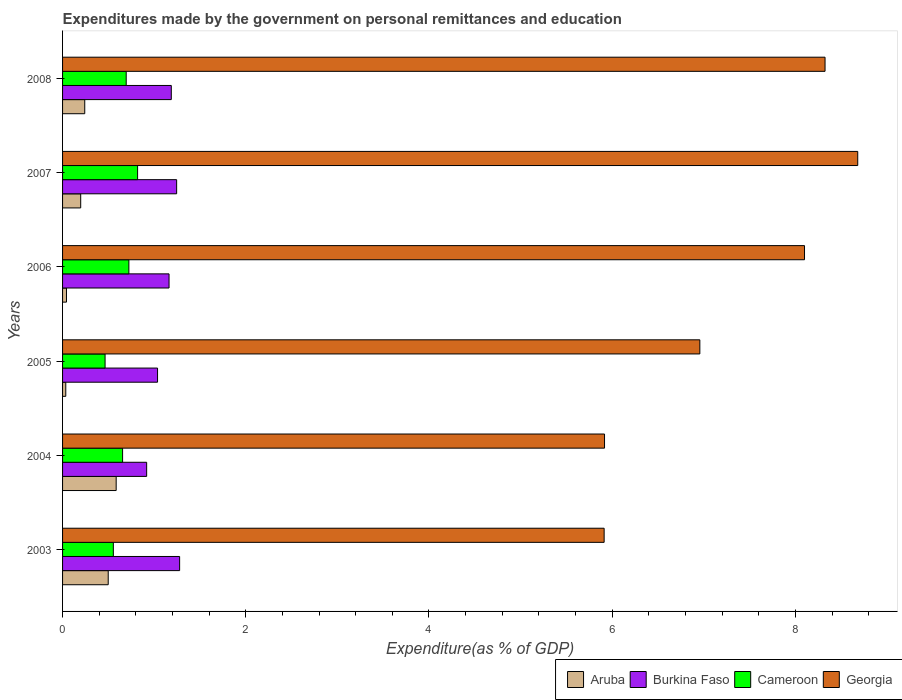How many different coloured bars are there?
Make the answer very short. 4. How many groups of bars are there?
Provide a succinct answer. 6. Are the number of bars on each tick of the Y-axis equal?
Provide a succinct answer. Yes. How many bars are there on the 2nd tick from the top?
Make the answer very short. 4. How many bars are there on the 4th tick from the bottom?
Make the answer very short. 4. What is the expenditures made by the government on personal remittances and education in Cameroon in 2005?
Your response must be concise. 0.46. Across all years, what is the maximum expenditures made by the government on personal remittances and education in Georgia?
Your response must be concise. 8.68. Across all years, what is the minimum expenditures made by the government on personal remittances and education in Burkina Faso?
Ensure brevity in your answer.  0.92. What is the total expenditures made by the government on personal remittances and education in Cameroon in the graph?
Make the answer very short. 3.91. What is the difference between the expenditures made by the government on personal remittances and education in Cameroon in 2004 and that in 2007?
Your answer should be very brief. -0.16. What is the difference between the expenditures made by the government on personal remittances and education in Aruba in 2004 and the expenditures made by the government on personal remittances and education in Burkina Faso in 2008?
Your answer should be compact. -0.6. What is the average expenditures made by the government on personal remittances and education in Burkina Faso per year?
Ensure brevity in your answer.  1.14. In the year 2008, what is the difference between the expenditures made by the government on personal remittances and education in Georgia and expenditures made by the government on personal remittances and education in Aruba?
Give a very brief answer. 8.08. What is the ratio of the expenditures made by the government on personal remittances and education in Burkina Faso in 2006 to that in 2007?
Make the answer very short. 0.93. Is the difference between the expenditures made by the government on personal remittances and education in Georgia in 2004 and 2005 greater than the difference between the expenditures made by the government on personal remittances and education in Aruba in 2004 and 2005?
Offer a terse response. No. What is the difference between the highest and the second highest expenditures made by the government on personal remittances and education in Aruba?
Keep it short and to the point. 0.09. What is the difference between the highest and the lowest expenditures made by the government on personal remittances and education in Georgia?
Give a very brief answer. 2.77. What does the 3rd bar from the top in 2006 represents?
Provide a succinct answer. Burkina Faso. What does the 1st bar from the bottom in 2004 represents?
Offer a terse response. Aruba. What is the difference between two consecutive major ticks on the X-axis?
Make the answer very short. 2. Does the graph contain any zero values?
Offer a very short reply. No. Does the graph contain grids?
Ensure brevity in your answer.  No. Where does the legend appear in the graph?
Offer a terse response. Bottom right. How many legend labels are there?
Ensure brevity in your answer.  4. What is the title of the graph?
Give a very brief answer. Expenditures made by the government on personal remittances and education. Does "China" appear as one of the legend labels in the graph?
Offer a terse response. No. What is the label or title of the X-axis?
Give a very brief answer. Expenditure(as % of GDP). What is the Expenditure(as % of GDP) in Aruba in 2003?
Make the answer very short. 0.5. What is the Expenditure(as % of GDP) in Burkina Faso in 2003?
Keep it short and to the point. 1.28. What is the Expenditure(as % of GDP) of Cameroon in 2003?
Your answer should be very brief. 0.55. What is the Expenditure(as % of GDP) in Georgia in 2003?
Keep it short and to the point. 5.91. What is the Expenditure(as % of GDP) of Aruba in 2004?
Provide a short and direct response. 0.59. What is the Expenditure(as % of GDP) of Burkina Faso in 2004?
Keep it short and to the point. 0.92. What is the Expenditure(as % of GDP) of Cameroon in 2004?
Offer a terse response. 0.66. What is the Expenditure(as % of GDP) of Georgia in 2004?
Give a very brief answer. 5.92. What is the Expenditure(as % of GDP) of Aruba in 2005?
Provide a succinct answer. 0.04. What is the Expenditure(as % of GDP) of Burkina Faso in 2005?
Your response must be concise. 1.04. What is the Expenditure(as % of GDP) of Cameroon in 2005?
Provide a short and direct response. 0.46. What is the Expenditure(as % of GDP) of Georgia in 2005?
Give a very brief answer. 6.96. What is the Expenditure(as % of GDP) in Aruba in 2006?
Give a very brief answer. 0.04. What is the Expenditure(as % of GDP) of Burkina Faso in 2006?
Your response must be concise. 1.16. What is the Expenditure(as % of GDP) in Cameroon in 2006?
Provide a succinct answer. 0.72. What is the Expenditure(as % of GDP) of Georgia in 2006?
Ensure brevity in your answer.  8.1. What is the Expenditure(as % of GDP) of Aruba in 2007?
Your answer should be compact. 0.2. What is the Expenditure(as % of GDP) of Burkina Faso in 2007?
Ensure brevity in your answer.  1.25. What is the Expenditure(as % of GDP) of Cameroon in 2007?
Your answer should be compact. 0.82. What is the Expenditure(as % of GDP) in Georgia in 2007?
Offer a terse response. 8.68. What is the Expenditure(as % of GDP) of Aruba in 2008?
Give a very brief answer. 0.24. What is the Expenditure(as % of GDP) in Burkina Faso in 2008?
Your response must be concise. 1.19. What is the Expenditure(as % of GDP) in Cameroon in 2008?
Give a very brief answer. 0.69. What is the Expenditure(as % of GDP) of Georgia in 2008?
Ensure brevity in your answer.  8.32. Across all years, what is the maximum Expenditure(as % of GDP) of Aruba?
Offer a terse response. 0.59. Across all years, what is the maximum Expenditure(as % of GDP) of Burkina Faso?
Keep it short and to the point. 1.28. Across all years, what is the maximum Expenditure(as % of GDP) in Cameroon?
Give a very brief answer. 0.82. Across all years, what is the maximum Expenditure(as % of GDP) in Georgia?
Offer a very short reply. 8.68. Across all years, what is the minimum Expenditure(as % of GDP) of Aruba?
Offer a very short reply. 0.04. Across all years, what is the minimum Expenditure(as % of GDP) of Burkina Faso?
Ensure brevity in your answer.  0.92. Across all years, what is the minimum Expenditure(as % of GDP) of Cameroon?
Offer a terse response. 0.46. Across all years, what is the minimum Expenditure(as % of GDP) of Georgia?
Offer a very short reply. 5.91. What is the total Expenditure(as % of GDP) in Aruba in the graph?
Provide a succinct answer. 1.6. What is the total Expenditure(as % of GDP) of Burkina Faso in the graph?
Ensure brevity in your answer.  6.83. What is the total Expenditure(as % of GDP) in Cameroon in the graph?
Offer a terse response. 3.91. What is the total Expenditure(as % of GDP) of Georgia in the graph?
Ensure brevity in your answer.  43.89. What is the difference between the Expenditure(as % of GDP) of Aruba in 2003 and that in 2004?
Provide a succinct answer. -0.09. What is the difference between the Expenditure(as % of GDP) in Burkina Faso in 2003 and that in 2004?
Ensure brevity in your answer.  0.36. What is the difference between the Expenditure(as % of GDP) of Cameroon in 2003 and that in 2004?
Offer a very short reply. -0.1. What is the difference between the Expenditure(as % of GDP) in Georgia in 2003 and that in 2004?
Offer a very short reply. -0. What is the difference between the Expenditure(as % of GDP) of Aruba in 2003 and that in 2005?
Give a very brief answer. 0.46. What is the difference between the Expenditure(as % of GDP) in Burkina Faso in 2003 and that in 2005?
Your response must be concise. 0.24. What is the difference between the Expenditure(as % of GDP) in Cameroon in 2003 and that in 2005?
Offer a very short reply. 0.09. What is the difference between the Expenditure(as % of GDP) in Georgia in 2003 and that in 2005?
Your response must be concise. -1.04. What is the difference between the Expenditure(as % of GDP) of Aruba in 2003 and that in 2006?
Provide a succinct answer. 0.46. What is the difference between the Expenditure(as % of GDP) in Burkina Faso in 2003 and that in 2006?
Keep it short and to the point. 0.12. What is the difference between the Expenditure(as % of GDP) of Cameroon in 2003 and that in 2006?
Give a very brief answer. -0.17. What is the difference between the Expenditure(as % of GDP) of Georgia in 2003 and that in 2006?
Provide a succinct answer. -2.19. What is the difference between the Expenditure(as % of GDP) in Aruba in 2003 and that in 2007?
Make the answer very short. 0.3. What is the difference between the Expenditure(as % of GDP) of Burkina Faso in 2003 and that in 2007?
Give a very brief answer. 0.03. What is the difference between the Expenditure(as % of GDP) in Cameroon in 2003 and that in 2007?
Make the answer very short. -0.26. What is the difference between the Expenditure(as % of GDP) of Georgia in 2003 and that in 2007?
Provide a short and direct response. -2.77. What is the difference between the Expenditure(as % of GDP) in Aruba in 2003 and that in 2008?
Ensure brevity in your answer.  0.26. What is the difference between the Expenditure(as % of GDP) of Burkina Faso in 2003 and that in 2008?
Keep it short and to the point. 0.09. What is the difference between the Expenditure(as % of GDP) in Cameroon in 2003 and that in 2008?
Your answer should be compact. -0.14. What is the difference between the Expenditure(as % of GDP) in Georgia in 2003 and that in 2008?
Give a very brief answer. -2.41. What is the difference between the Expenditure(as % of GDP) in Aruba in 2004 and that in 2005?
Offer a terse response. 0.55. What is the difference between the Expenditure(as % of GDP) of Burkina Faso in 2004 and that in 2005?
Ensure brevity in your answer.  -0.12. What is the difference between the Expenditure(as % of GDP) in Cameroon in 2004 and that in 2005?
Keep it short and to the point. 0.19. What is the difference between the Expenditure(as % of GDP) of Georgia in 2004 and that in 2005?
Ensure brevity in your answer.  -1.04. What is the difference between the Expenditure(as % of GDP) in Aruba in 2004 and that in 2006?
Keep it short and to the point. 0.54. What is the difference between the Expenditure(as % of GDP) of Burkina Faso in 2004 and that in 2006?
Your response must be concise. -0.24. What is the difference between the Expenditure(as % of GDP) in Cameroon in 2004 and that in 2006?
Offer a very short reply. -0.07. What is the difference between the Expenditure(as % of GDP) in Georgia in 2004 and that in 2006?
Make the answer very short. -2.18. What is the difference between the Expenditure(as % of GDP) of Aruba in 2004 and that in 2007?
Give a very brief answer. 0.39. What is the difference between the Expenditure(as % of GDP) in Burkina Faso in 2004 and that in 2007?
Offer a very short reply. -0.33. What is the difference between the Expenditure(as % of GDP) in Cameroon in 2004 and that in 2007?
Make the answer very short. -0.16. What is the difference between the Expenditure(as % of GDP) of Georgia in 2004 and that in 2007?
Your response must be concise. -2.76. What is the difference between the Expenditure(as % of GDP) in Aruba in 2004 and that in 2008?
Offer a terse response. 0.34. What is the difference between the Expenditure(as % of GDP) in Burkina Faso in 2004 and that in 2008?
Make the answer very short. -0.27. What is the difference between the Expenditure(as % of GDP) in Cameroon in 2004 and that in 2008?
Your answer should be compact. -0.04. What is the difference between the Expenditure(as % of GDP) in Georgia in 2004 and that in 2008?
Provide a short and direct response. -2.41. What is the difference between the Expenditure(as % of GDP) in Aruba in 2005 and that in 2006?
Provide a short and direct response. -0.01. What is the difference between the Expenditure(as % of GDP) of Burkina Faso in 2005 and that in 2006?
Your answer should be very brief. -0.13. What is the difference between the Expenditure(as % of GDP) in Cameroon in 2005 and that in 2006?
Keep it short and to the point. -0.26. What is the difference between the Expenditure(as % of GDP) of Georgia in 2005 and that in 2006?
Your answer should be compact. -1.14. What is the difference between the Expenditure(as % of GDP) in Aruba in 2005 and that in 2007?
Give a very brief answer. -0.16. What is the difference between the Expenditure(as % of GDP) in Burkina Faso in 2005 and that in 2007?
Make the answer very short. -0.21. What is the difference between the Expenditure(as % of GDP) of Cameroon in 2005 and that in 2007?
Your answer should be very brief. -0.35. What is the difference between the Expenditure(as % of GDP) of Georgia in 2005 and that in 2007?
Your response must be concise. -1.72. What is the difference between the Expenditure(as % of GDP) in Aruba in 2005 and that in 2008?
Ensure brevity in your answer.  -0.21. What is the difference between the Expenditure(as % of GDP) in Burkina Faso in 2005 and that in 2008?
Your answer should be very brief. -0.15. What is the difference between the Expenditure(as % of GDP) of Cameroon in 2005 and that in 2008?
Offer a terse response. -0.23. What is the difference between the Expenditure(as % of GDP) of Georgia in 2005 and that in 2008?
Your answer should be compact. -1.37. What is the difference between the Expenditure(as % of GDP) of Aruba in 2006 and that in 2007?
Provide a succinct answer. -0.16. What is the difference between the Expenditure(as % of GDP) of Burkina Faso in 2006 and that in 2007?
Provide a succinct answer. -0.08. What is the difference between the Expenditure(as % of GDP) in Cameroon in 2006 and that in 2007?
Provide a succinct answer. -0.1. What is the difference between the Expenditure(as % of GDP) of Georgia in 2006 and that in 2007?
Your answer should be compact. -0.58. What is the difference between the Expenditure(as % of GDP) in Aruba in 2006 and that in 2008?
Your answer should be very brief. -0.2. What is the difference between the Expenditure(as % of GDP) of Burkina Faso in 2006 and that in 2008?
Offer a terse response. -0.02. What is the difference between the Expenditure(as % of GDP) in Cameroon in 2006 and that in 2008?
Make the answer very short. 0.03. What is the difference between the Expenditure(as % of GDP) of Georgia in 2006 and that in 2008?
Offer a very short reply. -0.22. What is the difference between the Expenditure(as % of GDP) of Aruba in 2007 and that in 2008?
Give a very brief answer. -0.04. What is the difference between the Expenditure(as % of GDP) in Burkina Faso in 2007 and that in 2008?
Give a very brief answer. 0.06. What is the difference between the Expenditure(as % of GDP) of Cameroon in 2007 and that in 2008?
Ensure brevity in your answer.  0.12. What is the difference between the Expenditure(as % of GDP) of Georgia in 2007 and that in 2008?
Keep it short and to the point. 0.36. What is the difference between the Expenditure(as % of GDP) of Aruba in 2003 and the Expenditure(as % of GDP) of Burkina Faso in 2004?
Your answer should be very brief. -0.42. What is the difference between the Expenditure(as % of GDP) in Aruba in 2003 and the Expenditure(as % of GDP) in Cameroon in 2004?
Your answer should be very brief. -0.16. What is the difference between the Expenditure(as % of GDP) of Aruba in 2003 and the Expenditure(as % of GDP) of Georgia in 2004?
Give a very brief answer. -5.42. What is the difference between the Expenditure(as % of GDP) of Burkina Faso in 2003 and the Expenditure(as % of GDP) of Cameroon in 2004?
Give a very brief answer. 0.62. What is the difference between the Expenditure(as % of GDP) of Burkina Faso in 2003 and the Expenditure(as % of GDP) of Georgia in 2004?
Your answer should be compact. -4.64. What is the difference between the Expenditure(as % of GDP) of Cameroon in 2003 and the Expenditure(as % of GDP) of Georgia in 2004?
Keep it short and to the point. -5.36. What is the difference between the Expenditure(as % of GDP) of Aruba in 2003 and the Expenditure(as % of GDP) of Burkina Faso in 2005?
Make the answer very short. -0.54. What is the difference between the Expenditure(as % of GDP) in Aruba in 2003 and the Expenditure(as % of GDP) in Cameroon in 2005?
Keep it short and to the point. 0.03. What is the difference between the Expenditure(as % of GDP) of Aruba in 2003 and the Expenditure(as % of GDP) of Georgia in 2005?
Offer a terse response. -6.46. What is the difference between the Expenditure(as % of GDP) in Burkina Faso in 2003 and the Expenditure(as % of GDP) in Cameroon in 2005?
Your response must be concise. 0.81. What is the difference between the Expenditure(as % of GDP) in Burkina Faso in 2003 and the Expenditure(as % of GDP) in Georgia in 2005?
Provide a succinct answer. -5.68. What is the difference between the Expenditure(as % of GDP) in Cameroon in 2003 and the Expenditure(as % of GDP) in Georgia in 2005?
Provide a short and direct response. -6.4. What is the difference between the Expenditure(as % of GDP) in Aruba in 2003 and the Expenditure(as % of GDP) in Burkina Faso in 2006?
Make the answer very short. -0.66. What is the difference between the Expenditure(as % of GDP) of Aruba in 2003 and the Expenditure(as % of GDP) of Cameroon in 2006?
Offer a terse response. -0.23. What is the difference between the Expenditure(as % of GDP) of Aruba in 2003 and the Expenditure(as % of GDP) of Georgia in 2006?
Offer a terse response. -7.6. What is the difference between the Expenditure(as % of GDP) in Burkina Faso in 2003 and the Expenditure(as % of GDP) in Cameroon in 2006?
Give a very brief answer. 0.55. What is the difference between the Expenditure(as % of GDP) of Burkina Faso in 2003 and the Expenditure(as % of GDP) of Georgia in 2006?
Ensure brevity in your answer.  -6.82. What is the difference between the Expenditure(as % of GDP) of Cameroon in 2003 and the Expenditure(as % of GDP) of Georgia in 2006?
Your answer should be compact. -7.55. What is the difference between the Expenditure(as % of GDP) of Aruba in 2003 and the Expenditure(as % of GDP) of Burkina Faso in 2007?
Make the answer very short. -0.75. What is the difference between the Expenditure(as % of GDP) of Aruba in 2003 and the Expenditure(as % of GDP) of Cameroon in 2007?
Offer a very short reply. -0.32. What is the difference between the Expenditure(as % of GDP) of Aruba in 2003 and the Expenditure(as % of GDP) of Georgia in 2007?
Give a very brief answer. -8.18. What is the difference between the Expenditure(as % of GDP) of Burkina Faso in 2003 and the Expenditure(as % of GDP) of Cameroon in 2007?
Provide a succinct answer. 0.46. What is the difference between the Expenditure(as % of GDP) in Burkina Faso in 2003 and the Expenditure(as % of GDP) in Georgia in 2007?
Provide a succinct answer. -7.4. What is the difference between the Expenditure(as % of GDP) of Cameroon in 2003 and the Expenditure(as % of GDP) of Georgia in 2007?
Your answer should be compact. -8.13. What is the difference between the Expenditure(as % of GDP) of Aruba in 2003 and the Expenditure(as % of GDP) of Burkina Faso in 2008?
Offer a terse response. -0.69. What is the difference between the Expenditure(as % of GDP) in Aruba in 2003 and the Expenditure(as % of GDP) in Cameroon in 2008?
Ensure brevity in your answer.  -0.2. What is the difference between the Expenditure(as % of GDP) of Aruba in 2003 and the Expenditure(as % of GDP) of Georgia in 2008?
Your answer should be very brief. -7.83. What is the difference between the Expenditure(as % of GDP) of Burkina Faso in 2003 and the Expenditure(as % of GDP) of Cameroon in 2008?
Provide a short and direct response. 0.58. What is the difference between the Expenditure(as % of GDP) of Burkina Faso in 2003 and the Expenditure(as % of GDP) of Georgia in 2008?
Your answer should be very brief. -7.05. What is the difference between the Expenditure(as % of GDP) of Cameroon in 2003 and the Expenditure(as % of GDP) of Georgia in 2008?
Offer a very short reply. -7.77. What is the difference between the Expenditure(as % of GDP) of Aruba in 2004 and the Expenditure(as % of GDP) of Burkina Faso in 2005?
Your answer should be very brief. -0.45. What is the difference between the Expenditure(as % of GDP) in Aruba in 2004 and the Expenditure(as % of GDP) in Cameroon in 2005?
Your answer should be compact. 0.12. What is the difference between the Expenditure(as % of GDP) in Aruba in 2004 and the Expenditure(as % of GDP) in Georgia in 2005?
Offer a terse response. -6.37. What is the difference between the Expenditure(as % of GDP) in Burkina Faso in 2004 and the Expenditure(as % of GDP) in Cameroon in 2005?
Provide a succinct answer. 0.45. What is the difference between the Expenditure(as % of GDP) of Burkina Faso in 2004 and the Expenditure(as % of GDP) of Georgia in 2005?
Offer a very short reply. -6.04. What is the difference between the Expenditure(as % of GDP) of Cameroon in 2004 and the Expenditure(as % of GDP) of Georgia in 2005?
Offer a terse response. -6.3. What is the difference between the Expenditure(as % of GDP) in Aruba in 2004 and the Expenditure(as % of GDP) in Burkina Faso in 2006?
Provide a succinct answer. -0.58. What is the difference between the Expenditure(as % of GDP) in Aruba in 2004 and the Expenditure(as % of GDP) in Cameroon in 2006?
Ensure brevity in your answer.  -0.14. What is the difference between the Expenditure(as % of GDP) in Aruba in 2004 and the Expenditure(as % of GDP) in Georgia in 2006?
Give a very brief answer. -7.51. What is the difference between the Expenditure(as % of GDP) of Burkina Faso in 2004 and the Expenditure(as % of GDP) of Cameroon in 2006?
Make the answer very short. 0.19. What is the difference between the Expenditure(as % of GDP) in Burkina Faso in 2004 and the Expenditure(as % of GDP) in Georgia in 2006?
Provide a short and direct response. -7.18. What is the difference between the Expenditure(as % of GDP) of Cameroon in 2004 and the Expenditure(as % of GDP) of Georgia in 2006?
Offer a very short reply. -7.44. What is the difference between the Expenditure(as % of GDP) of Aruba in 2004 and the Expenditure(as % of GDP) of Burkina Faso in 2007?
Provide a succinct answer. -0.66. What is the difference between the Expenditure(as % of GDP) of Aruba in 2004 and the Expenditure(as % of GDP) of Cameroon in 2007?
Give a very brief answer. -0.23. What is the difference between the Expenditure(as % of GDP) in Aruba in 2004 and the Expenditure(as % of GDP) in Georgia in 2007?
Give a very brief answer. -8.1. What is the difference between the Expenditure(as % of GDP) in Burkina Faso in 2004 and the Expenditure(as % of GDP) in Cameroon in 2007?
Ensure brevity in your answer.  0.1. What is the difference between the Expenditure(as % of GDP) in Burkina Faso in 2004 and the Expenditure(as % of GDP) in Georgia in 2007?
Your answer should be very brief. -7.76. What is the difference between the Expenditure(as % of GDP) of Cameroon in 2004 and the Expenditure(as % of GDP) of Georgia in 2007?
Your response must be concise. -8.03. What is the difference between the Expenditure(as % of GDP) of Aruba in 2004 and the Expenditure(as % of GDP) of Burkina Faso in 2008?
Provide a succinct answer. -0.6. What is the difference between the Expenditure(as % of GDP) in Aruba in 2004 and the Expenditure(as % of GDP) in Cameroon in 2008?
Provide a succinct answer. -0.11. What is the difference between the Expenditure(as % of GDP) in Aruba in 2004 and the Expenditure(as % of GDP) in Georgia in 2008?
Offer a very short reply. -7.74. What is the difference between the Expenditure(as % of GDP) of Burkina Faso in 2004 and the Expenditure(as % of GDP) of Cameroon in 2008?
Your response must be concise. 0.22. What is the difference between the Expenditure(as % of GDP) of Burkina Faso in 2004 and the Expenditure(as % of GDP) of Georgia in 2008?
Your response must be concise. -7.41. What is the difference between the Expenditure(as % of GDP) of Cameroon in 2004 and the Expenditure(as % of GDP) of Georgia in 2008?
Offer a very short reply. -7.67. What is the difference between the Expenditure(as % of GDP) of Aruba in 2005 and the Expenditure(as % of GDP) of Burkina Faso in 2006?
Give a very brief answer. -1.13. What is the difference between the Expenditure(as % of GDP) of Aruba in 2005 and the Expenditure(as % of GDP) of Cameroon in 2006?
Your response must be concise. -0.69. What is the difference between the Expenditure(as % of GDP) in Aruba in 2005 and the Expenditure(as % of GDP) in Georgia in 2006?
Keep it short and to the point. -8.06. What is the difference between the Expenditure(as % of GDP) in Burkina Faso in 2005 and the Expenditure(as % of GDP) in Cameroon in 2006?
Provide a short and direct response. 0.31. What is the difference between the Expenditure(as % of GDP) in Burkina Faso in 2005 and the Expenditure(as % of GDP) in Georgia in 2006?
Your answer should be compact. -7.06. What is the difference between the Expenditure(as % of GDP) in Cameroon in 2005 and the Expenditure(as % of GDP) in Georgia in 2006?
Keep it short and to the point. -7.64. What is the difference between the Expenditure(as % of GDP) in Aruba in 2005 and the Expenditure(as % of GDP) in Burkina Faso in 2007?
Provide a succinct answer. -1.21. What is the difference between the Expenditure(as % of GDP) of Aruba in 2005 and the Expenditure(as % of GDP) of Cameroon in 2007?
Provide a short and direct response. -0.78. What is the difference between the Expenditure(as % of GDP) of Aruba in 2005 and the Expenditure(as % of GDP) of Georgia in 2007?
Offer a terse response. -8.65. What is the difference between the Expenditure(as % of GDP) of Burkina Faso in 2005 and the Expenditure(as % of GDP) of Cameroon in 2007?
Keep it short and to the point. 0.22. What is the difference between the Expenditure(as % of GDP) of Burkina Faso in 2005 and the Expenditure(as % of GDP) of Georgia in 2007?
Your response must be concise. -7.64. What is the difference between the Expenditure(as % of GDP) in Cameroon in 2005 and the Expenditure(as % of GDP) in Georgia in 2007?
Provide a short and direct response. -8.22. What is the difference between the Expenditure(as % of GDP) of Aruba in 2005 and the Expenditure(as % of GDP) of Burkina Faso in 2008?
Ensure brevity in your answer.  -1.15. What is the difference between the Expenditure(as % of GDP) in Aruba in 2005 and the Expenditure(as % of GDP) in Cameroon in 2008?
Your answer should be very brief. -0.66. What is the difference between the Expenditure(as % of GDP) in Aruba in 2005 and the Expenditure(as % of GDP) in Georgia in 2008?
Your answer should be very brief. -8.29. What is the difference between the Expenditure(as % of GDP) in Burkina Faso in 2005 and the Expenditure(as % of GDP) in Cameroon in 2008?
Offer a very short reply. 0.34. What is the difference between the Expenditure(as % of GDP) in Burkina Faso in 2005 and the Expenditure(as % of GDP) in Georgia in 2008?
Your response must be concise. -7.29. What is the difference between the Expenditure(as % of GDP) in Cameroon in 2005 and the Expenditure(as % of GDP) in Georgia in 2008?
Ensure brevity in your answer.  -7.86. What is the difference between the Expenditure(as % of GDP) of Aruba in 2006 and the Expenditure(as % of GDP) of Burkina Faso in 2007?
Your answer should be very brief. -1.2. What is the difference between the Expenditure(as % of GDP) of Aruba in 2006 and the Expenditure(as % of GDP) of Cameroon in 2007?
Your answer should be compact. -0.78. What is the difference between the Expenditure(as % of GDP) in Aruba in 2006 and the Expenditure(as % of GDP) in Georgia in 2007?
Keep it short and to the point. -8.64. What is the difference between the Expenditure(as % of GDP) of Burkina Faso in 2006 and the Expenditure(as % of GDP) of Cameroon in 2007?
Your response must be concise. 0.34. What is the difference between the Expenditure(as % of GDP) of Burkina Faso in 2006 and the Expenditure(as % of GDP) of Georgia in 2007?
Offer a very short reply. -7.52. What is the difference between the Expenditure(as % of GDP) in Cameroon in 2006 and the Expenditure(as % of GDP) in Georgia in 2007?
Ensure brevity in your answer.  -7.96. What is the difference between the Expenditure(as % of GDP) of Aruba in 2006 and the Expenditure(as % of GDP) of Burkina Faso in 2008?
Provide a short and direct response. -1.14. What is the difference between the Expenditure(as % of GDP) of Aruba in 2006 and the Expenditure(as % of GDP) of Cameroon in 2008?
Offer a terse response. -0.65. What is the difference between the Expenditure(as % of GDP) of Aruba in 2006 and the Expenditure(as % of GDP) of Georgia in 2008?
Make the answer very short. -8.28. What is the difference between the Expenditure(as % of GDP) of Burkina Faso in 2006 and the Expenditure(as % of GDP) of Cameroon in 2008?
Ensure brevity in your answer.  0.47. What is the difference between the Expenditure(as % of GDP) of Burkina Faso in 2006 and the Expenditure(as % of GDP) of Georgia in 2008?
Your answer should be very brief. -7.16. What is the difference between the Expenditure(as % of GDP) in Cameroon in 2006 and the Expenditure(as % of GDP) in Georgia in 2008?
Ensure brevity in your answer.  -7.6. What is the difference between the Expenditure(as % of GDP) of Aruba in 2007 and the Expenditure(as % of GDP) of Burkina Faso in 2008?
Keep it short and to the point. -0.99. What is the difference between the Expenditure(as % of GDP) in Aruba in 2007 and the Expenditure(as % of GDP) in Cameroon in 2008?
Provide a short and direct response. -0.5. What is the difference between the Expenditure(as % of GDP) of Aruba in 2007 and the Expenditure(as % of GDP) of Georgia in 2008?
Your response must be concise. -8.13. What is the difference between the Expenditure(as % of GDP) in Burkina Faso in 2007 and the Expenditure(as % of GDP) in Cameroon in 2008?
Ensure brevity in your answer.  0.55. What is the difference between the Expenditure(as % of GDP) in Burkina Faso in 2007 and the Expenditure(as % of GDP) in Georgia in 2008?
Your answer should be very brief. -7.08. What is the difference between the Expenditure(as % of GDP) of Cameroon in 2007 and the Expenditure(as % of GDP) of Georgia in 2008?
Your response must be concise. -7.5. What is the average Expenditure(as % of GDP) in Aruba per year?
Provide a short and direct response. 0.27. What is the average Expenditure(as % of GDP) in Burkina Faso per year?
Your response must be concise. 1.14. What is the average Expenditure(as % of GDP) of Cameroon per year?
Your response must be concise. 0.65. What is the average Expenditure(as % of GDP) in Georgia per year?
Give a very brief answer. 7.31. In the year 2003, what is the difference between the Expenditure(as % of GDP) of Aruba and Expenditure(as % of GDP) of Burkina Faso?
Give a very brief answer. -0.78. In the year 2003, what is the difference between the Expenditure(as % of GDP) of Aruba and Expenditure(as % of GDP) of Cameroon?
Your response must be concise. -0.06. In the year 2003, what is the difference between the Expenditure(as % of GDP) of Aruba and Expenditure(as % of GDP) of Georgia?
Offer a very short reply. -5.41. In the year 2003, what is the difference between the Expenditure(as % of GDP) in Burkina Faso and Expenditure(as % of GDP) in Cameroon?
Offer a terse response. 0.72. In the year 2003, what is the difference between the Expenditure(as % of GDP) of Burkina Faso and Expenditure(as % of GDP) of Georgia?
Give a very brief answer. -4.63. In the year 2003, what is the difference between the Expenditure(as % of GDP) in Cameroon and Expenditure(as % of GDP) in Georgia?
Offer a terse response. -5.36. In the year 2004, what is the difference between the Expenditure(as % of GDP) in Aruba and Expenditure(as % of GDP) in Burkina Faso?
Make the answer very short. -0.33. In the year 2004, what is the difference between the Expenditure(as % of GDP) in Aruba and Expenditure(as % of GDP) in Cameroon?
Offer a very short reply. -0.07. In the year 2004, what is the difference between the Expenditure(as % of GDP) of Aruba and Expenditure(as % of GDP) of Georgia?
Provide a short and direct response. -5.33. In the year 2004, what is the difference between the Expenditure(as % of GDP) of Burkina Faso and Expenditure(as % of GDP) of Cameroon?
Offer a very short reply. 0.26. In the year 2004, what is the difference between the Expenditure(as % of GDP) in Burkina Faso and Expenditure(as % of GDP) in Georgia?
Give a very brief answer. -5. In the year 2004, what is the difference between the Expenditure(as % of GDP) of Cameroon and Expenditure(as % of GDP) of Georgia?
Provide a succinct answer. -5.26. In the year 2005, what is the difference between the Expenditure(as % of GDP) in Aruba and Expenditure(as % of GDP) in Burkina Faso?
Your answer should be very brief. -1. In the year 2005, what is the difference between the Expenditure(as % of GDP) of Aruba and Expenditure(as % of GDP) of Cameroon?
Give a very brief answer. -0.43. In the year 2005, what is the difference between the Expenditure(as % of GDP) in Aruba and Expenditure(as % of GDP) in Georgia?
Ensure brevity in your answer.  -6.92. In the year 2005, what is the difference between the Expenditure(as % of GDP) in Burkina Faso and Expenditure(as % of GDP) in Cameroon?
Offer a terse response. 0.57. In the year 2005, what is the difference between the Expenditure(as % of GDP) of Burkina Faso and Expenditure(as % of GDP) of Georgia?
Provide a short and direct response. -5.92. In the year 2005, what is the difference between the Expenditure(as % of GDP) in Cameroon and Expenditure(as % of GDP) in Georgia?
Offer a terse response. -6.49. In the year 2006, what is the difference between the Expenditure(as % of GDP) in Aruba and Expenditure(as % of GDP) in Burkina Faso?
Your response must be concise. -1.12. In the year 2006, what is the difference between the Expenditure(as % of GDP) in Aruba and Expenditure(as % of GDP) in Cameroon?
Keep it short and to the point. -0.68. In the year 2006, what is the difference between the Expenditure(as % of GDP) of Aruba and Expenditure(as % of GDP) of Georgia?
Ensure brevity in your answer.  -8.06. In the year 2006, what is the difference between the Expenditure(as % of GDP) of Burkina Faso and Expenditure(as % of GDP) of Cameroon?
Offer a terse response. 0.44. In the year 2006, what is the difference between the Expenditure(as % of GDP) in Burkina Faso and Expenditure(as % of GDP) in Georgia?
Offer a very short reply. -6.94. In the year 2006, what is the difference between the Expenditure(as % of GDP) of Cameroon and Expenditure(as % of GDP) of Georgia?
Your response must be concise. -7.38. In the year 2007, what is the difference between the Expenditure(as % of GDP) in Aruba and Expenditure(as % of GDP) in Burkina Faso?
Your response must be concise. -1.05. In the year 2007, what is the difference between the Expenditure(as % of GDP) of Aruba and Expenditure(as % of GDP) of Cameroon?
Make the answer very short. -0.62. In the year 2007, what is the difference between the Expenditure(as % of GDP) in Aruba and Expenditure(as % of GDP) in Georgia?
Your response must be concise. -8.48. In the year 2007, what is the difference between the Expenditure(as % of GDP) in Burkina Faso and Expenditure(as % of GDP) in Cameroon?
Keep it short and to the point. 0.43. In the year 2007, what is the difference between the Expenditure(as % of GDP) of Burkina Faso and Expenditure(as % of GDP) of Georgia?
Provide a short and direct response. -7.44. In the year 2007, what is the difference between the Expenditure(as % of GDP) in Cameroon and Expenditure(as % of GDP) in Georgia?
Ensure brevity in your answer.  -7.86. In the year 2008, what is the difference between the Expenditure(as % of GDP) in Aruba and Expenditure(as % of GDP) in Burkina Faso?
Give a very brief answer. -0.94. In the year 2008, what is the difference between the Expenditure(as % of GDP) in Aruba and Expenditure(as % of GDP) in Cameroon?
Offer a very short reply. -0.45. In the year 2008, what is the difference between the Expenditure(as % of GDP) of Aruba and Expenditure(as % of GDP) of Georgia?
Make the answer very short. -8.08. In the year 2008, what is the difference between the Expenditure(as % of GDP) in Burkina Faso and Expenditure(as % of GDP) in Cameroon?
Provide a succinct answer. 0.49. In the year 2008, what is the difference between the Expenditure(as % of GDP) in Burkina Faso and Expenditure(as % of GDP) in Georgia?
Your answer should be compact. -7.14. In the year 2008, what is the difference between the Expenditure(as % of GDP) of Cameroon and Expenditure(as % of GDP) of Georgia?
Ensure brevity in your answer.  -7.63. What is the ratio of the Expenditure(as % of GDP) in Aruba in 2003 to that in 2004?
Provide a succinct answer. 0.85. What is the ratio of the Expenditure(as % of GDP) of Burkina Faso in 2003 to that in 2004?
Your answer should be compact. 1.39. What is the ratio of the Expenditure(as % of GDP) of Cameroon in 2003 to that in 2004?
Offer a terse response. 0.85. What is the ratio of the Expenditure(as % of GDP) in Georgia in 2003 to that in 2004?
Your answer should be very brief. 1. What is the ratio of the Expenditure(as % of GDP) in Aruba in 2003 to that in 2005?
Keep it short and to the point. 14.17. What is the ratio of the Expenditure(as % of GDP) in Burkina Faso in 2003 to that in 2005?
Your answer should be very brief. 1.23. What is the ratio of the Expenditure(as % of GDP) of Cameroon in 2003 to that in 2005?
Offer a terse response. 1.19. What is the ratio of the Expenditure(as % of GDP) in Georgia in 2003 to that in 2005?
Your response must be concise. 0.85. What is the ratio of the Expenditure(as % of GDP) of Aruba in 2003 to that in 2006?
Your answer should be very brief. 11.65. What is the ratio of the Expenditure(as % of GDP) of Burkina Faso in 2003 to that in 2006?
Provide a succinct answer. 1.1. What is the ratio of the Expenditure(as % of GDP) in Cameroon in 2003 to that in 2006?
Offer a very short reply. 0.77. What is the ratio of the Expenditure(as % of GDP) of Georgia in 2003 to that in 2006?
Your answer should be very brief. 0.73. What is the ratio of the Expenditure(as % of GDP) of Aruba in 2003 to that in 2007?
Offer a terse response. 2.52. What is the ratio of the Expenditure(as % of GDP) of Burkina Faso in 2003 to that in 2007?
Give a very brief answer. 1.03. What is the ratio of the Expenditure(as % of GDP) in Cameroon in 2003 to that in 2007?
Offer a terse response. 0.68. What is the ratio of the Expenditure(as % of GDP) of Georgia in 2003 to that in 2007?
Give a very brief answer. 0.68. What is the ratio of the Expenditure(as % of GDP) in Aruba in 2003 to that in 2008?
Provide a succinct answer. 2.06. What is the ratio of the Expenditure(as % of GDP) of Burkina Faso in 2003 to that in 2008?
Offer a terse response. 1.08. What is the ratio of the Expenditure(as % of GDP) of Cameroon in 2003 to that in 2008?
Give a very brief answer. 0.8. What is the ratio of the Expenditure(as % of GDP) in Georgia in 2003 to that in 2008?
Your answer should be compact. 0.71. What is the ratio of the Expenditure(as % of GDP) in Aruba in 2004 to that in 2005?
Offer a terse response. 16.64. What is the ratio of the Expenditure(as % of GDP) in Burkina Faso in 2004 to that in 2005?
Make the answer very short. 0.89. What is the ratio of the Expenditure(as % of GDP) in Cameroon in 2004 to that in 2005?
Offer a terse response. 1.41. What is the ratio of the Expenditure(as % of GDP) in Georgia in 2004 to that in 2005?
Your answer should be very brief. 0.85. What is the ratio of the Expenditure(as % of GDP) of Aruba in 2004 to that in 2006?
Offer a very short reply. 13.68. What is the ratio of the Expenditure(as % of GDP) in Burkina Faso in 2004 to that in 2006?
Keep it short and to the point. 0.79. What is the ratio of the Expenditure(as % of GDP) of Cameroon in 2004 to that in 2006?
Provide a short and direct response. 0.91. What is the ratio of the Expenditure(as % of GDP) of Georgia in 2004 to that in 2006?
Keep it short and to the point. 0.73. What is the ratio of the Expenditure(as % of GDP) of Aruba in 2004 to that in 2007?
Provide a short and direct response. 2.96. What is the ratio of the Expenditure(as % of GDP) of Burkina Faso in 2004 to that in 2007?
Your answer should be very brief. 0.74. What is the ratio of the Expenditure(as % of GDP) in Cameroon in 2004 to that in 2007?
Offer a very short reply. 0.8. What is the ratio of the Expenditure(as % of GDP) of Georgia in 2004 to that in 2007?
Provide a succinct answer. 0.68. What is the ratio of the Expenditure(as % of GDP) in Aruba in 2004 to that in 2008?
Provide a succinct answer. 2.42. What is the ratio of the Expenditure(as % of GDP) of Burkina Faso in 2004 to that in 2008?
Offer a very short reply. 0.77. What is the ratio of the Expenditure(as % of GDP) in Cameroon in 2004 to that in 2008?
Make the answer very short. 0.94. What is the ratio of the Expenditure(as % of GDP) of Georgia in 2004 to that in 2008?
Give a very brief answer. 0.71. What is the ratio of the Expenditure(as % of GDP) in Aruba in 2005 to that in 2006?
Provide a succinct answer. 0.82. What is the ratio of the Expenditure(as % of GDP) in Burkina Faso in 2005 to that in 2006?
Provide a short and direct response. 0.89. What is the ratio of the Expenditure(as % of GDP) in Cameroon in 2005 to that in 2006?
Provide a short and direct response. 0.64. What is the ratio of the Expenditure(as % of GDP) of Georgia in 2005 to that in 2006?
Provide a short and direct response. 0.86. What is the ratio of the Expenditure(as % of GDP) of Aruba in 2005 to that in 2007?
Offer a terse response. 0.18. What is the ratio of the Expenditure(as % of GDP) in Burkina Faso in 2005 to that in 2007?
Your answer should be compact. 0.83. What is the ratio of the Expenditure(as % of GDP) in Cameroon in 2005 to that in 2007?
Give a very brief answer. 0.57. What is the ratio of the Expenditure(as % of GDP) of Georgia in 2005 to that in 2007?
Offer a very short reply. 0.8. What is the ratio of the Expenditure(as % of GDP) in Aruba in 2005 to that in 2008?
Provide a short and direct response. 0.15. What is the ratio of the Expenditure(as % of GDP) in Burkina Faso in 2005 to that in 2008?
Provide a short and direct response. 0.87. What is the ratio of the Expenditure(as % of GDP) in Cameroon in 2005 to that in 2008?
Your answer should be compact. 0.67. What is the ratio of the Expenditure(as % of GDP) in Georgia in 2005 to that in 2008?
Give a very brief answer. 0.84. What is the ratio of the Expenditure(as % of GDP) in Aruba in 2006 to that in 2007?
Provide a short and direct response. 0.22. What is the ratio of the Expenditure(as % of GDP) in Burkina Faso in 2006 to that in 2007?
Offer a terse response. 0.93. What is the ratio of the Expenditure(as % of GDP) of Cameroon in 2006 to that in 2007?
Your answer should be very brief. 0.88. What is the ratio of the Expenditure(as % of GDP) in Georgia in 2006 to that in 2007?
Offer a terse response. 0.93. What is the ratio of the Expenditure(as % of GDP) in Aruba in 2006 to that in 2008?
Give a very brief answer. 0.18. What is the ratio of the Expenditure(as % of GDP) in Burkina Faso in 2006 to that in 2008?
Provide a short and direct response. 0.98. What is the ratio of the Expenditure(as % of GDP) of Cameroon in 2006 to that in 2008?
Make the answer very short. 1.04. What is the ratio of the Expenditure(as % of GDP) in Georgia in 2006 to that in 2008?
Provide a short and direct response. 0.97. What is the ratio of the Expenditure(as % of GDP) in Aruba in 2007 to that in 2008?
Your answer should be very brief. 0.82. What is the ratio of the Expenditure(as % of GDP) of Burkina Faso in 2007 to that in 2008?
Your answer should be very brief. 1.05. What is the ratio of the Expenditure(as % of GDP) in Cameroon in 2007 to that in 2008?
Your answer should be very brief. 1.18. What is the ratio of the Expenditure(as % of GDP) of Georgia in 2007 to that in 2008?
Your response must be concise. 1.04. What is the difference between the highest and the second highest Expenditure(as % of GDP) of Aruba?
Your answer should be very brief. 0.09. What is the difference between the highest and the second highest Expenditure(as % of GDP) of Burkina Faso?
Your answer should be very brief. 0.03. What is the difference between the highest and the second highest Expenditure(as % of GDP) of Cameroon?
Your answer should be compact. 0.1. What is the difference between the highest and the second highest Expenditure(as % of GDP) in Georgia?
Offer a very short reply. 0.36. What is the difference between the highest and the lowest Expenditure(as % of GDP) of Aruba?
Your answer should be compact. 0.55. What is the difference between the highest and the lowest Expenditure(as % of GDP) of Burkina Faso?
Your response must be concise. 0.36. What is the difference between the highest and the lowest Expenditure(as % of GDP) in Cameroon?
Make the answer very short. 0.35. What is the difference between the highest and the lowest Expenditure(as % of GDP) of Georgia?
Your answer should be compact. 2.77. 